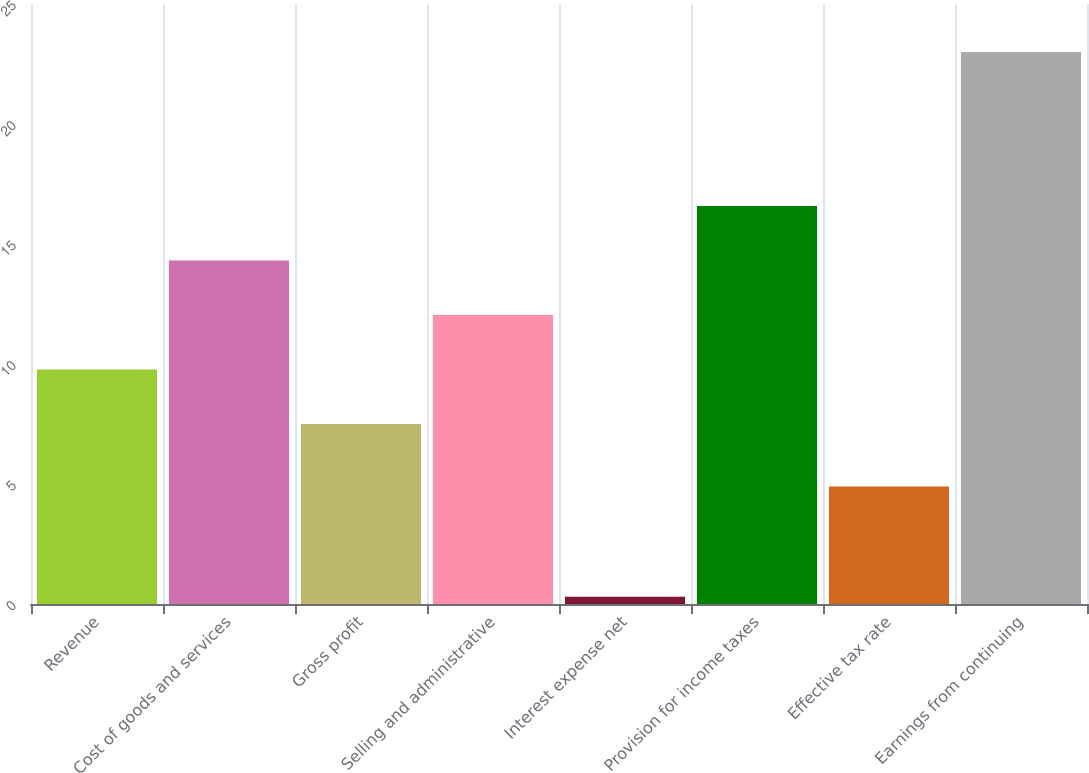Convert chart. <chart><loc_0><loc_0><loc_500><loc_500><bar_chart><fcel>Revenue<fcel>Cost of goods and services<fcel>Gross profit<fcel>Selling and administrative<fcel>Interest expense net<fcel>Provision for income taxes<fcel>Effective tax rate<fcel>Earnings from continuing<nl><fcel>9.77<fcel>14.31<fcel>7.5<fcel>12.04<fcel>0.3<fcel>16.58<fcel>4.9<fcel>23<nl></chart> 